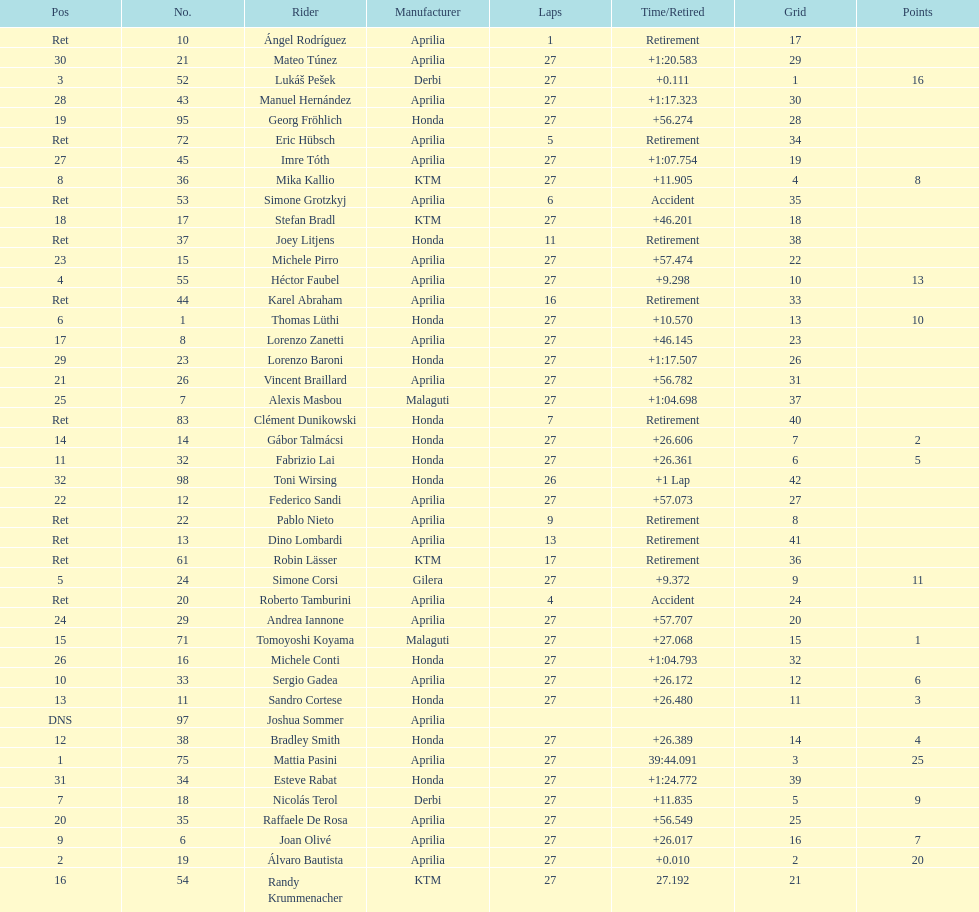Out of all the people who have points, who has the least? Tomoyoshi Koyama. 